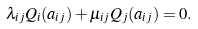Convert formula to latex. <formula><loc_0><loc_0><loc_500><loc_500>\lambda _ { i j } Q _ { i } ( a _ { i j } ) + \mu _ { i j } Q _ { j } ( a _ { i j } ) = 0 .</formula> 